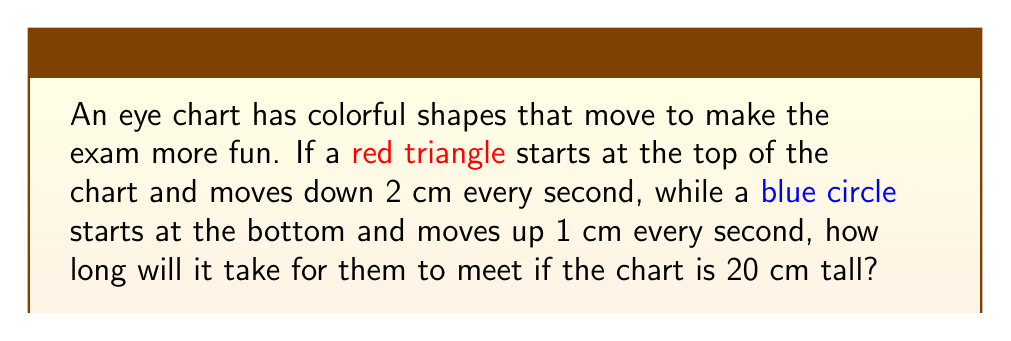Can you answer this question? Let's approach this step-by-step:

1) First, let's define our variables:
   $h$ = height of the chart = 20 cm
   $v_t$ = speed of the triangle (downward) = 2 cm/s
   $v_c$ = speed of the circle (upward) = 1 cm/s

2) We need to find the time $t$ when the shapes meet. At this time, the distance traveled by both shapes will equal the height of the chart.

3) We can express this as an equation:
   $v_t t + v_c t = h$

4) Substituting our known values:
   $2t + t = 20$

5) Simplifying:
   $3t = 20$

6) Solving for $t$:
   $t = \frac{20}{3} \approx 6.67$ seconds

Therefore, it will take about 6.67 seconds for the shapes to meet.
Answer: $\frac{20}{3}$ seconds 